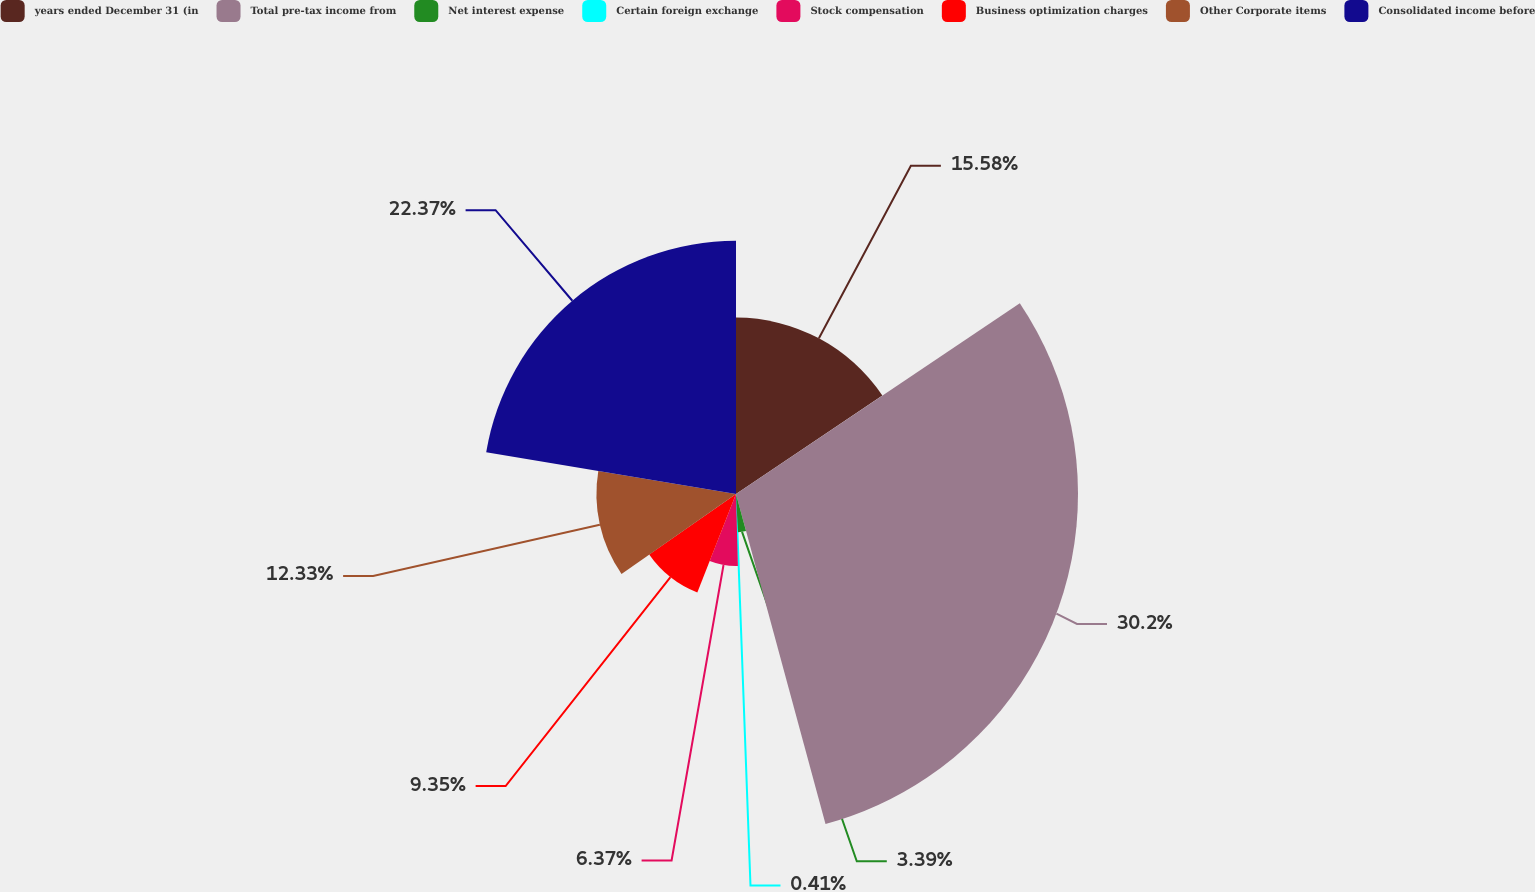Convert chart. <chart><loc_0><loc_0><loc_500><loc_500><pie_chart><fcel>years ended December 31 (in<fcel>Total pre-tax income from<fcel>Net interest expense<fcel>Certain foreign exchange<fcel>Stock compensation<fcel>Business optimization charges<fcel>Other Corporate items<fcel>Consolidated income before<nl><fcel>15.58%<fcel>30.21%<fcel>3.39%<fcel>0.41%<fcel>6.37%<fcel>9.35%<fcel>12.33%<fcel>22.37%<nl></chart> 